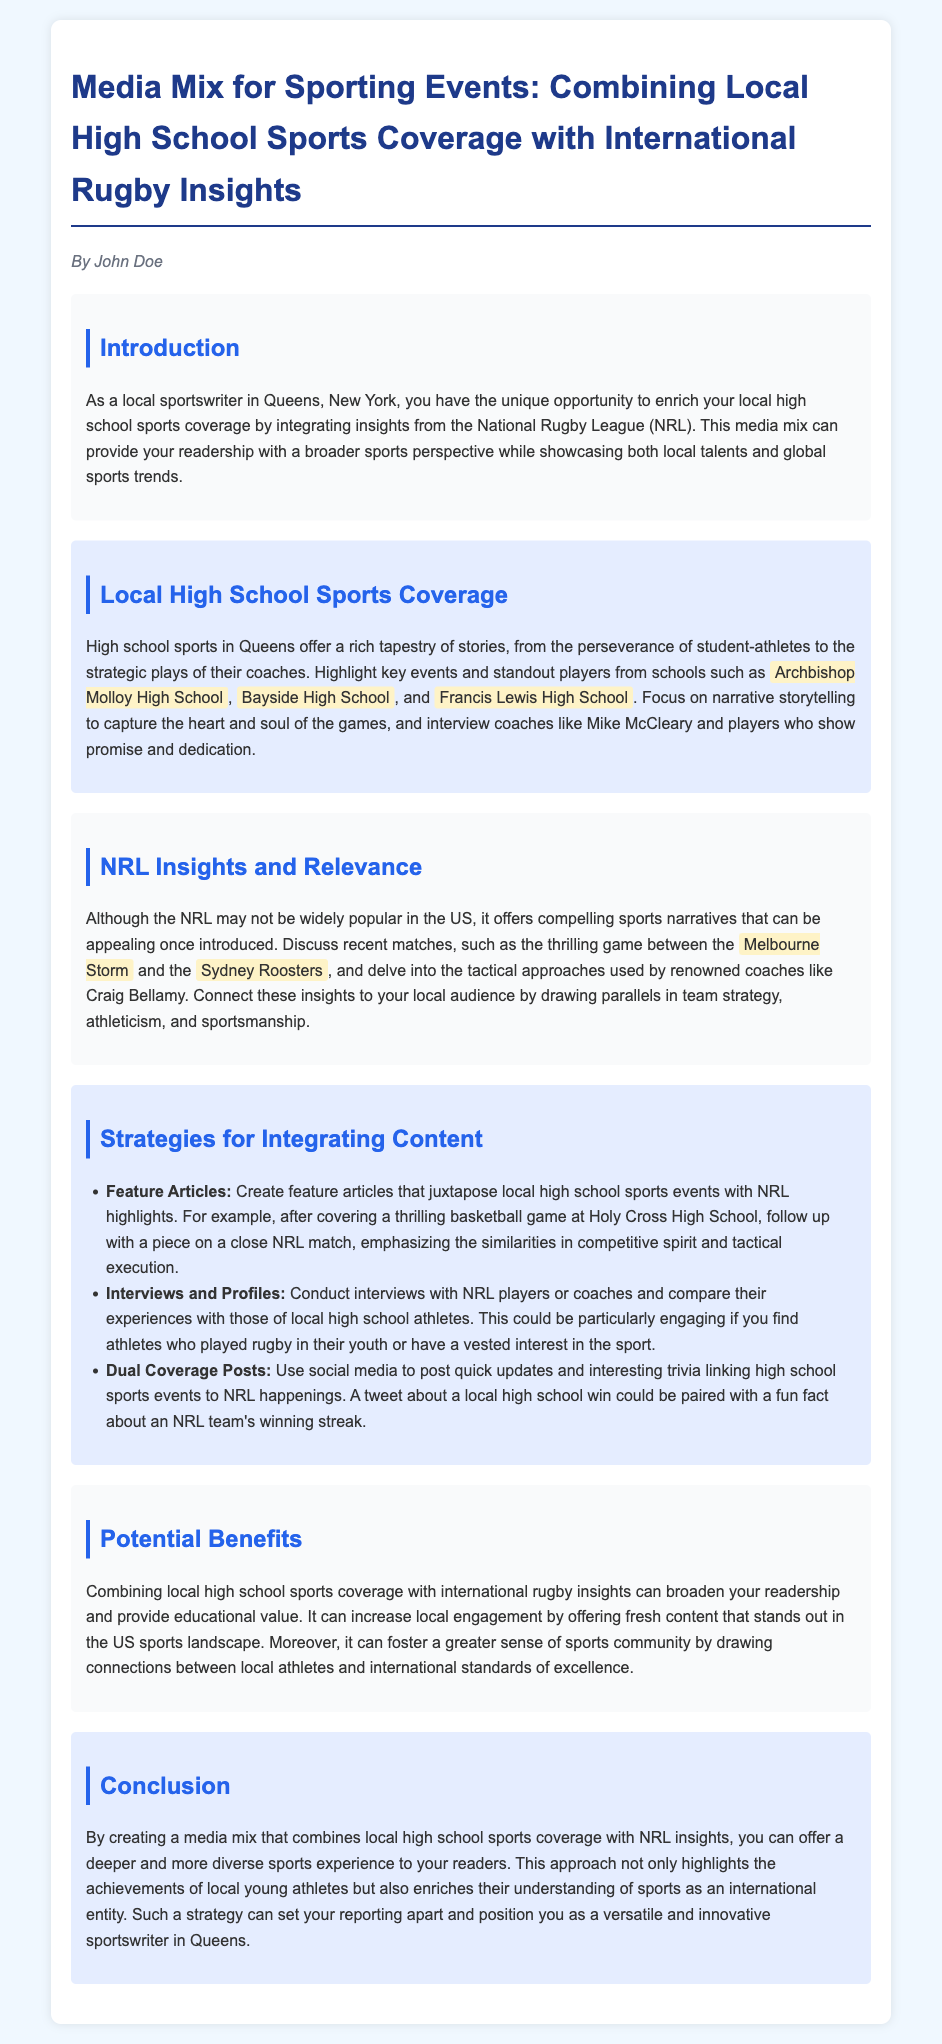What is the title of the document? The title is found at the beginning of the document and summarizes its focus on media mix for sporting events.
Answer: Media Mix for Sporting Events: Combining Local High School Sports Coverage with International Rugby Insights Who is the author of the document? The author's name is mentioned under the title in an italicized format.
Answer: John Doe Which high school is highlighted first in local coverage? The document lists several schools, and the first mentioned school exemplifies the focus of local coverage.
Answer: Archbishop Molloy High School What is a recommended strategy for integrating content? The document mentions several strategies, one of which emphasizes feature articles comparing different sports events.
Answer: Feature Articles What is the purpose of combining local sports coverage with NRL insights? The document outlines the goal of the media mix, which is to provide a deeper understanding of sports.
Answer: Broaden readership and provide educational value Who are the two NRL teams mentioned in the insights section? The document provides specific examples of teams involved in a recent thrilling match.
Answer: Melbourne Storm and Sydney Roosters What type of athletes should be targeted for interviews according to the strategies? The document discusses interviewing athletes who have some background in rugby or interest in the sport.
Answer: NRL players or coaches What is one potential benefit of this media mix? The document lists various advantages of combining these coverage types, focusing on local engagement.
Answer: Increased local engagement Which term describes the overarching theme of the document? The document aims to highlight the connections between local and international sports.
Answer: Media mix 